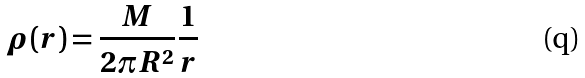Convert formula to latex. <formula><loc_0><loc_0><loc_500><loc_500>\rho ( r ) = \frac { M } { 2 \pi R ^ { 2 } } \frac { 1 } { r }</formula> 